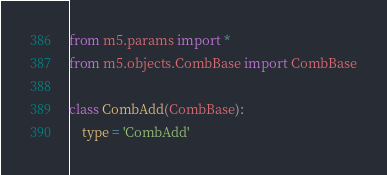<code> <loc_0><loc_0><loc_500><loc_500><_Python_>
from m5.params import *
from m5.objects.CombBase import CombBase

class CombAdd(CombBase):
    type = 'CombAdd'</code> 